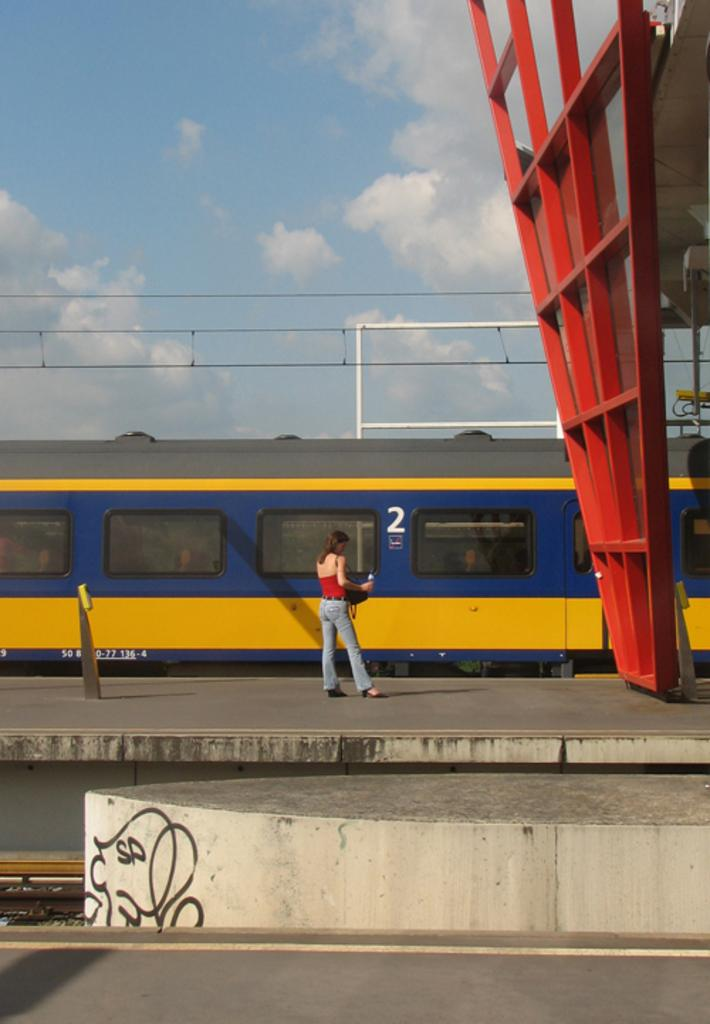What is the woman doing in the image? The woman is standing on a platform in the image. What can be seen behind the woman? There is a train and wires visible in the background. What is the condition of the sky in the image? The sky is visible in the background, and clouds are present. What type of shoe is the band wearing while taking a bath in the image? There is no band or bath present in the image; it features a woman standing on a platform with a train and wires in the background. 